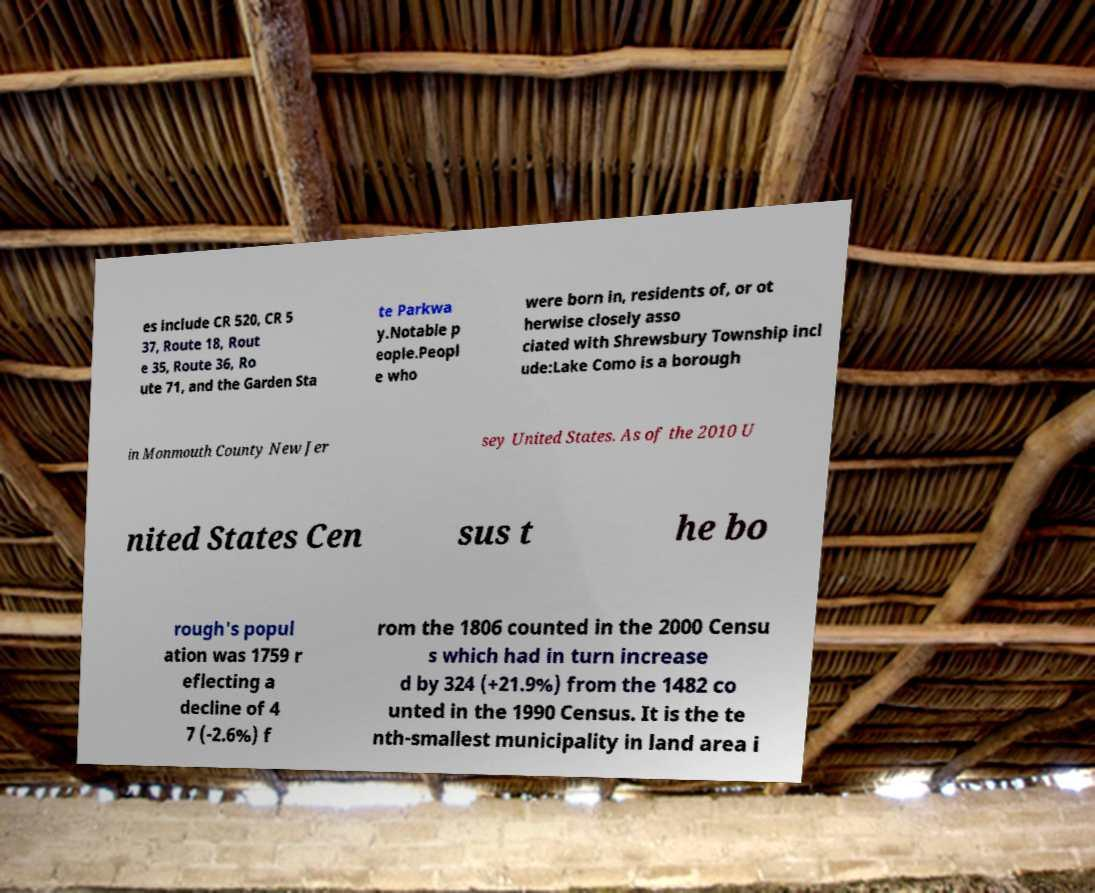I need the written content from this picture converted into text. Can you do that? es include CR 520, CR 5 37, Route 18, Rout e 35, Route 36, Ro ute 71, and the Garden Sta te Parkwa y.Notable p eople.Peopl e who were born in, residents of, or ot herwise closely asso ciated with Shrewsbury Township incl ude:Lake Como is a borough in Monmouth County New Jer sey United States. As of the 2010 U nited States Cen sus t he bo rough's popul ation was 1759 r eflecting a decline of 4 7 (-2.6%) f rom the 1806 counted in the 2000 Censu s which had in turn increase d by 324 (+21.9%) from the 1482 co unted in the 1990 Census. It is the te nth-smallest municipality in land area i 